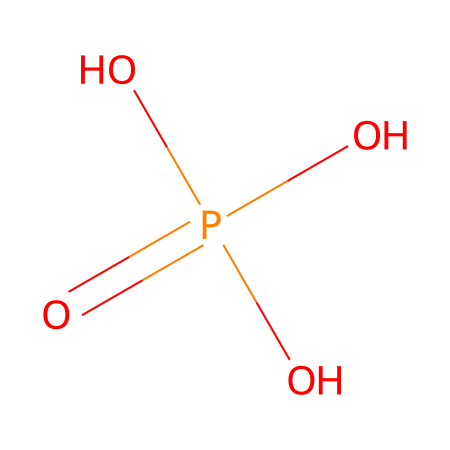What is the name of this chemical? The SMILES representation indicates this compound is phosphoric acid, which is commonly used as a food additive.
Answer: phosphoric acid How many oxygen atoms are in phosphoric acid? The SMILES structure shows four oxygen (O) atoms attached to a phosphorus (P) atom, which can be counted directly from the representation.
Answer: four What is the central atom in this compound? The phosphorus atom (P) is central to the structure and connects to the oxygen atoms, making it the main component of phosphoric acid.
Answer: phosphorus How many hydroxyl groups are present in the chemical structure? The structure shows three -OH (hydroxyl) groups attached to the central phosphorus, identified by the three O atoms connected to H atoms in the representation.
Answer: three Why is this compound considered an acid? It is classified as an acid due to the presence of hydrogen ions (H+) that can be released when dissolved in water, which is indicated by the hydroxyl groups in the structure.
Answer: because of hydrogen ions What type of reaction can phosphoric acid undergo? Phosphoric acid can undergo neutralization reactions with bases, where it donates protons (H+) to form water and a salt.
Answer: neutralization reactions What is the oxidation state of phosphorus in phosphoric acid? In phosphoric acid, phosphorus has an oxidation state of +5, derived from its bonding with the four oxygen atoms in the structure.
Answer: +5 